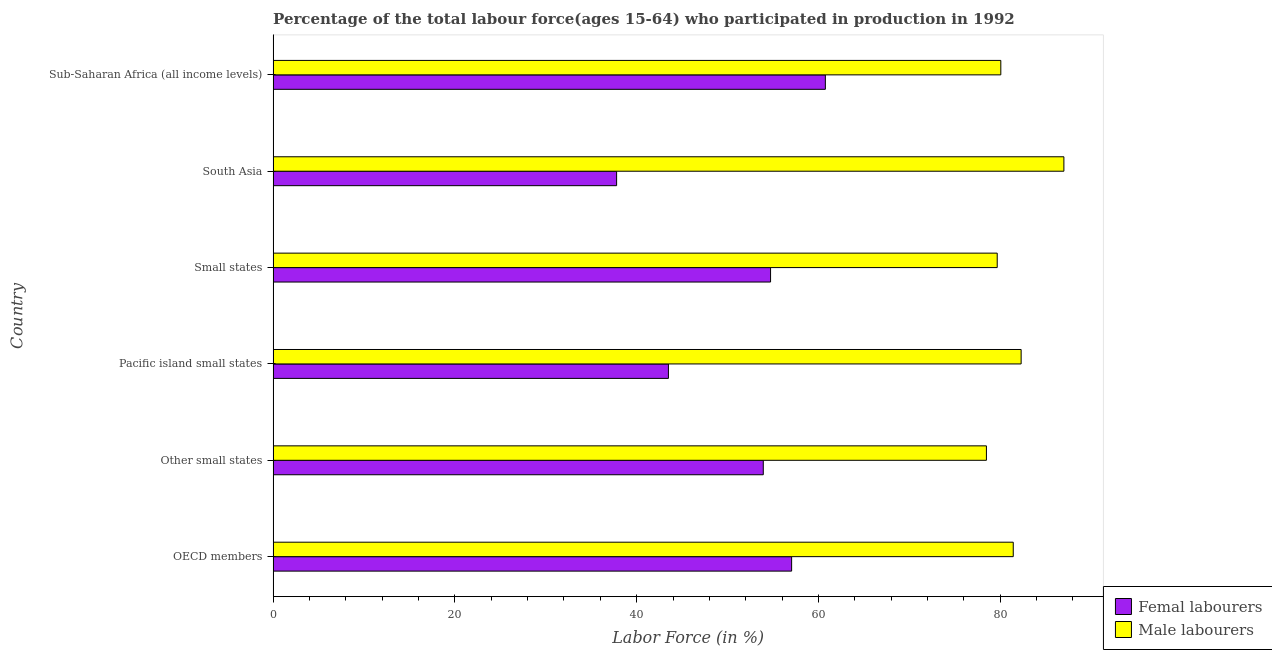How many different coloured bars are there?
Provide a short and direct response. 2. How many bars are there on the 2nd tick from the top?
Provide a succinct answer. 2. How many bars are there on the 1st tick from the bottom?
Offer a very short reply. 2. What is the label of the 6th group of bars from the top?
Make the answer very short. OECD members. In how many cases, is the number of bars for a given country not equal to the number of legend labels?
Provide a succinct answer. 0. What is the percentage of male labour force in Other small states?
Your answer should be compact. 78.48. Across all countries, what is the maximum percentage of female labor force?
Offer a terse response. 60.76. Across all countries, what is the minimum percentage of female labor force?
Offer a terse response. 37.79. What is the total percentage of female labor force in the graph?
Make the answer very short. 307.74. What is the difference between the percentage of female labor force in Other small states and that in Small states?
Ensure brevity in your answer.  -0.8. What is the difference between the percentage of male labour force in Pacific island small states and the percentage of female labor force in Other small states?
Provide a short and direct response. 28.37. What is the average percentage of female labor force per country?
Give a very brief answer. 51.29. What is the difference between the percentage of male labour force and percentage of female labor force in South Asia?
Offer a terse response. 49.21. In how many countries, is the percentage of male labour force greater than 32 %?
Your answer should be compact. 6. What is the ratio of the percentage of female labor force in Small states to that in Sub-Saharan Africa (all income levels)?
Provide a succinct answer. 0.9. What is the difference between the highest and the second highest percentage of male labour force?
Provide a succinct answer. 4.7. What is the difference between the highest and the lowest percentage of female labor force?
Your response must be concise. 22.97. In how many countries, is the percentage of female labor force greater than the average percentage of female labor force taken over all countries?
Offer a very short reply. 4. Is the sum of the percentage of male labour force in Other small states and Pacific island small states greater than the maximum percentage of female labor force across all countries?
Offer a terse response. Yes. What does the 1st bar from the top in Other small states represents?
Your response must be concise. Male labourers. What does the 1st bar from the bottom in Sub-Saharan Africa (all income levels) represents?
Provide a short and direct response. Femal labourers. How many bars are there?
Offer a very short reply. 12. Are all the bars in the graph horizontal?
Your answer should be very brief. Yes. What is the difference between two consecutive major ticks on the X-axis?
Give a very brief answer. 20. Does the graph contain any zero values?
Give a very brief answer. No. Where does the legend appear in the graph?
Your response must be concise. Bottom right. How many legend labels are there?
Offer a very short reply. 2. How are the legend labels stacked?
Offer a very short reply. Vertical. What is the title of the graph?
Offer a terse response. Percentage of the total labour force(ages 15-64) who participated in production in 1992. What is the Labor Force (in %) in Femal labourers in OECD members?
Keep it short and to the point. 57.05. What is the Labor Force (in %) in Male labourers in OECD members?
Offer a very short reply. 81.43. What is the Labor Force (in %) in Femal labourers in Other small states?
Your answer should be compact. 53.93. What is the Labor Force (in %) in Male labourers in Other small states?
Offer a terse response. 78.48. What is the Labor Force (in %) in Femal labourers in Pacific island small states?
Your answer should be very brief. 43.49. What is the Labor Force (in %) in Male labourers in Pacific island small states?
Ensure brevity in your answer.  82.3. What is the Labor Force (in %) of Femal labourers in Small states?
Offer a terse response. 54.73. What is the Labor Force (in %) in Male labourers in Small states?
Your response must be concise. 79.66. What is the Labor Force (in %) in Femal labourers in South Asia?
Your response must be concise. 37.79. What is the Labor Force (in %) in Male labourers in South Asia?
Provide a succinct answer. 87. What is the Labor Force (in %) of Femal labourers in Sub-Saharan Africa (all income levels)?
Ensure brevity in your answer.  60.76. What is the Labor Force (in %) of Male labourers in Sub-Saharan Africa (all income levels)?
Your answer should be very brief. 80.06. Across all countries, what is the maximum Labor Force (in %) of Femal labourers?
Give a very brief answer. 60.76. Across all countries, what is the maximum Labor Force (in %) of Male labourers?
Your answer should be very brief. 87. Across all countries, what is the minimum Labor Force (in %) in Femal labourers?
Your answer should be very brief. 37.79. Across all countries, what is the minimum Labor Force (in %) of Male labourers?
Your answer should be very brief. 78.48. What is the total Labor Force (in %) of Femal labourers in the graph?
Give a very brief answer. 307.74. What is the total Labor Force (in %) of Male labourers in the graph?
Ensure brevity in your answer.  488.93. What is the difference between the Labor Force (in %) of Femal labourers in OECD members and that in Other small states?
Provide a succinct answer. 3.12. What is the difference between the Labor Force (in %) in Male labourers in OECD members and that in Other small states?
Your answer should be compact. 2.95. What is the difference between the Labor Force (in %) of Femal labourers in OECD members and that in Pacific island small states?
Ensure brevity in your answer.  13.55. What is the difference between the Labor Force (in %) in Male labourers in OECD members and that in Pacific island small states?
Provide a succinct answer. -0.87. What is the difference between the Labor Force (in %) in Femal labourers in OECD members and that in Small states?
Your answer should be very brief. 2.32. What is the difference between the Labor Force (in %) in Male labourers in OECD members and that in Small states?
Offer a terse response. 1.77. What is the difference between the Labor Force (in %) in Femal labourers in OECD members and that in South Asia?
Make the answer very short. 19.26. What is the difference between the Labor Force (in %) of Male labourers in OECD members and that in South Asia?
Offer a terse response. -5.57. What is the difference between the Labor Force (in %) in Femal labourers in OECD members and that in Sub-Saharan Africa (all income levels)?
Your answer should be compact. -3.71. What is the difference between the Labor Force (in %) in Male labourers in OECD members and that in Sub-Saharan Africa (all income levels)?
Offer a very short reply. 1.37. What is the difference between the Labor Force (in %) in Femal labourers in Other small states and that in Pacific island small states?
Provide a short and direct response. 10.44. What is the difference between the Labor Force (in %) in Male labourers in Other small states and that in Pacific island small states?
Provide a short and direct response. -3.82. What is the difference between the Labor Force (in %) of Femal labourers in Other small states and that in Small states?
Provide a succinct answer. -0.8. What is the difference between the Labor Force (in %) of Male labourers in Other small states and that in Small states?
Offer a terse response. -1.19. What is the difference between the Labor Force (in %) of Femal labourers in Other small states and that in South Asia?
Your response must be concise. 16.14. What is the difference between the Labor Force (in %) in Male labourers in Other small states and that in South Asia?
Keep it short and to the point. -8.52. What is the difference between the Labor Force (in %) of Femal labourers in Other small states and that in Sub-Saharan Africa (all income levels)?
Offer a terse response. -6.83. What is the difference between the Labor Force (in %) in Male labourers in Other small states and that in Sub-Saharan Africa (all income levels)?
Provide a short and direct response. -1.58. What is the difference between the Labor Force (in %) of Femal labourers in Pacific island small states and that in Small states?
Make the answer very short. -11.24. What is the difference between the Labor Force (in %) of Male labourers in Pacific island small states and that in Small states?
Keep it short and to the point. 2.63. What is the difference between the Labor Force (in %) in Femal labourers in Pacific island small states and that in South Asia?
Your answer should be compact. 5.7. What is the difference between the Labor Force (in %) of Male labourers in Pacific island small states and that in South Asia?
Your answer should be compact. -4.7. What is the difference between the Labor Force (in %) in Femal labourers in Pacific island small states and that in Sub-Saharan Africa (all income levels)?
Your answer should be compact. -17.27. What is the difference between the Labor Force (in %) in Male labourers in Pacific island small states and that in Sub-Saharan Africa (all income levels)?
Offer a terse response. 2.24. What is the difference between the Labor Force (in %) in Femal labourers in Small states and that in South Asia?
Your response must be concise. 16.94. What is the difference between the Labor Force (in %) of Male labourers in Small states and that in South Asia?
Provide a short and direct response. -7.34. What is the difference between the Labor Force (in %) in Femal labourers in Small states and that in Sub-Saharan Africa (all income levels)?
Make the answer very short. -6.03. What is the difference between the Labor Force (in %) of Male labourers in Small states and that in Sub-Saharan Africa (all income levels)?
Offer a terse response. -0.4. What is the difference between the Labor Force (in %) in Femal labourers in South Asia and that in Sub-Saharan Africa (all income levels)?
Give a very brief answer. -22.97. What is the difference between the Labor Force (in %) in Male labourers in South Asia and that in Sub-Saharan Africa (all income levels)?
Your answer should be very brief. 6.94. What is the difference between the Labor Force (in %) in Femal labourers in OECD members and the Labor Force (in %) in Male labourers in Other small states?
Provide a succinct answer. -21.43. What is the difference between the Labor Force (in %) of Femal labourers in OECD members and the Labor Force (in %) of Male labourers in Pacific island small states?
Provide a succinct answer. -25.25. What is the difference between the Labor Force (in %) in Femal labourers in OECD members and the Labor Force (in %) in Male labourers in Small states?
Your response must be concise. -22.62. What is the difference between the Labor Force (in %) in Femal labourers in OECD members and the Labor Force (in %) in Male labourers in South Asia?
Offer a terse response. -29.95. What is the difference between the Labor Force (in %) in Femal labourers in OECD members and the Labor Force (in %) in Male labourers in Sub-Saharan Africa (all income levels)?
Your answer should be compact. -23.01. What is the difference between the Labor Force (in %) in Femal labourers in Other small states and the Labor Force (in %) in Male labourers in Pacific island small states?
Your response must be concise. -28.37. What is the difference between the Labor Force (in %) in Femal labourers in Other small states and the Labor Force (in %) in Male labourers in Small states?
Keep it short and to the point. -25.74. What is the difference between the Labor Force (in %) in Femal labourers in Other small states and the Labor Force (in %) in Male labourers in South Asia?
Your response must be concise. -33.07. What is the difference between the Labor Force (in %) of Femal labourers in Other small states and the Labor Force (in %) of Male labourers in Sub-Saharan Africa (all income levels)?
Offer a very short reply. -26.13. What is the difference between the Labor Force (in %) in Femal labourers in Pacific island small states and the Labor Force (in %) in Male labourers in Small states?
Keep it short and to the point. -36.17. What is the difference between the Labor Force (in %) in Femal labourers in Pacific island small states and the Labor Force (in %) in Male labourers in South Asia?
Provide a succinct answer. -43.51. What is the difference between the Labor Force (in %) in Femal labourers in Pacific island small states and the Labor Force (in %) in Male labourers in Sub-Saharan Africa (all income levels)?
Offer a very short reply. -36.57. What is the difference between the Labor Force (in %) of Femal labourers in Small states and the Labor Force (in %) of Male labourers in South Asia?
Give a very brief answer. -32.27. What is the difference between the Labor Force (in %) in Femal labourers in Small states and the Labor Force (in %) in Male labourers in Sub-Saharan Africa (all income levels)?
Provide a short and direct response. -25.33. What is the difference between the Labor Force (in %) of Femal labourers in South Asia and the Labor Force (in %) of Male labourers in Sub-Saharan Africa (all income levels)?
Your answer should be compact. -42.27. What is the average Labor Force (in %) in Femal labourers per country?
Offer a terse response. 51.29. What is the average Labor Force (in %) in Male labourers per country?
Give a very brief answer. 81.49. What is the difference between the Labor Force (in %) in Femal labourers and Labor Force (in %) in Male labourers in OECD members?
Your answer should be compact. -24.38. What is the difference between the Labor Force (in %) in Femal labourers and Labor Force (in %) in Male labourers in Other small states?
Your answer should be very brief. -24.55. What is the difference between the Labor Force (in %) in Femal labourers and Labor Force (in %) in Male labourers in Pacific island small states?
Provide a short and direct response. -38.81. What is the difference between the Labor Force (in %) of Femal labourers and Labor Force (in %) of Male labourers in Small states?
Offer a very short reply. -24.94. What is the difference between the Labor Force (in %) in Femal labourers and Labor Force (in %) in Male labourers in South Asia?
Give a very brief answer. -49.21. What is the difference between the Labor Force (in %) in Femal labourers and Labor Force (in %) in Male labourers in Sub-Saharan Africa (all income levels)?
Make the answer very short. -19.3. What is the ratio of the Labor Force (in %) in Femal labourers in OECD members to that in Other small states?
Keep it short and to the point. 1.06. What is the ratio of the Labor Force (in %) of Male labourers in OECD members to that in Other small states?
Ensure brevity in your answer.  1.04. What is the ratio of the Labor Force (in %) of Femal labourers in OECD members to that in Pacific island small states?
Your answer should be very brief. 1.31. What is the ratio of the Labor Force (in %) in Femal labourers in OECD members to that in Small states?
Offer a very short reply. 1.04. What is the ratio of the Labor Force (in %) in Male labourers in OECD members to that in Small states?
Keep it short and to the point. 1.02. What is the ratio of the Labor Force (in %) of Femal labourers in OECD members to that in South Asia?
Offer a very short reply. 1.51. What is the ratio of the Labor Force (in %) in Male labourers in OECD members to that in South Asia?
Ensure brevity in your answer.  0.94. What is the ratio of the Labor Force (in %) of Femal labourers in OECD members to that in Sub-Saharan Africa (all income levels)?
Give a very brief answer. 0.94. What is the ratio of the Labor Force (in %) in Male labourers in OECD members to that in Sub-Saharan Africa (all income levels)?
Your answer should be very brief. 1.02. What is the ratio of the Labor Force (in %) in Femal labourers in Other small states to that in Pacific island small states?
Provide a succinct answer. 1.24. What is the ratio of the Labor Force (in %) in Male labourers in Other small states to that in Pacific island small states?
Ensure brevity in your answer.  0.95. What is the ratio of the Labor Force (in %) of Male labourers in Other small states to that in Small states?
Your answer should be very brief. 0.99. What is the ratio of the Labor Force (in %) of Femal labourers in Other small states to that in South Asia?
Keep it short and to the point. 1.43. What is the ratio of the Labor Force (in %) of Male labourers in Other small states to that in South Asia?
Ensure brevity in your answer.  0.9. What is the ratio of the Labor Force (in %) in Femal labourers in Other small states to that in Sub-Saharan Africa (all income levels)?
Offer a very short reply. 0.89. What is the ratio of the Labor Force (in %) in Male labourers in Other small states to that in Sub-Saharan Africa (all income levels)?
Keep it short and to the point. 0.98. What is the ratio of the Labor Force (in %) of Femal labourers in Pacific island small states to that in Small states?
Your answer should be very brief. 0.79. What is the ratio of the Labor Force (in %) of Male labourers in Pacific island small states to that in Small states?
Offer a very short reply. 1.03. What is the ratio of the Labor Force (in %) in Femal labourers in Pacific island small states to that in South Asia?
Your answer should be very brief. 1.15. What is the ratio of the Labor Force (in %) in Male labourers in Pacific island small states to that in South Asia?
Make the answer very short. 0.95. What is the ratio of the Labor Force (in %) in Femal labourers in Pacific island small states to that in Sub-Saharan Africa (all income levels)?
Give a very brief answer. 0.72. What is the ratio of the Labor Force (in %) in Male labourers in Pacific island small states to that in Sub-Saharan Africa (all income levels)?
Make the answer very short. 1.03. What is the ratio of the Labor Force (in %) in Femal labourers in Small states to that in South Asia?
Ensure brevity in your answer.  1.45. What is the ratio of the Labor Force (in %) in Male labourers in Small states to that in South Asia?
Offer a terse response. 0.92. What is the ratio of the Labor Force (in %) in Femal labourers in Small states to that in Sub-Saharan Africa (all income levels)?
Your answer should be very brief. 0.9. What is the ratio of the Labor Force (in %) in Male labourers in Small states to that in Sub-Saharan Africa (all income levels)?
Give a very brief answer. 1. What is the ratio of the Labor Force (in %) in Femal labourers in South Asia to that in Sub-Saharan Africa (all income levels)?
Your answer should be compact. 0.62. What is the ratio of the Labor Force (in %) of Male labourers in South Asia to that in Sub-Saharan Africa (all income levels)?
Provide a short and direct response. 1.09. What is the difference between the highest and the second highest Labor Force (in %) in Femal labourers?
Ensure brevity in your answer.  3.71. What is the difference between the highest and the second highest Labor Force (in %) in Male labourers?
Provide a short and direct response. 4.7. What is the difference between the highest and the lowest Labor Force (in %) of Femal labourers?
Offer a very short reply. 22.97. What is the difference between the highest and the lowest Labor Force (in %) of Male labourers?
Offer a terse response. 8.52. 